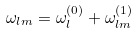<formula> <loc_0><loc_0><loc_500><loc_500>\omega _ { l m } = \omega _ { l } ^ { ( 0 ) } + \omega _ { l m } ^ { ( 1 ) }</formula> 